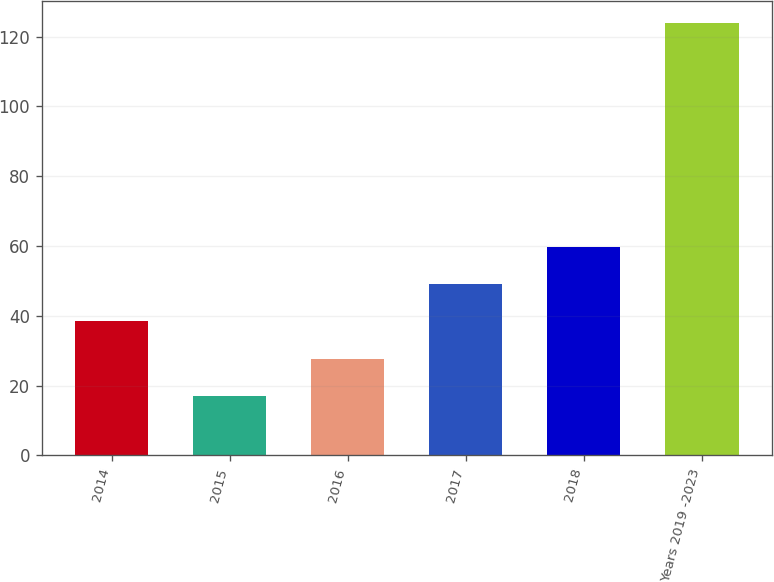Convert chart. <chart><loc_0><loc_0><loc_500><loc_500><bar_chart><fcel>2014<fcel>2015<fcel>2016<fcel>2017<fcel>2018<fcel>Years 2019 -2023<nl><fcel>38.38<fcel>17<fcel>27.69<fcel>49.07<fcel>59.76<fcel>123.9<nl></chart> 